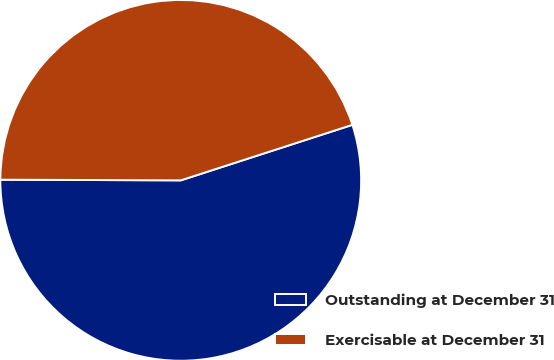<chart> <loc_0><loc_0><loc_500><loc_500><pie_chart><fcel>Outstanding at December 31<fcel>Exercisable at December 31<nl><fcel>55.04%<fcel>44.96%<nl></chart> 